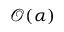<formula> <loc_0><loc_0><loc_500><loc_500>\mathcal { O } ( \alpha )</formula> 